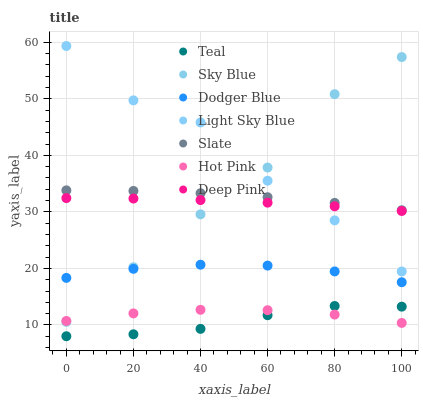Does Teal have the minimum area under the curve?
Answer yes or no. Yes. Does Light Sky Blue have the maximum area under the curve?
Answer yes or no. Yes. Does Slate have the minimum area under the curve?
Answer yes or no. No. Does Slate have the maximum area under the curve?
Answer yes or no. No. Is Deep Pink the smoothest?
Answer yes or no. Yes. Is Light Sky Blue the roughest?
Answer yes or no. Yes. Is Slate the smoothest?
Answer yes or no. No. Is Slate the roughest?
Answer yes or no. No. Does Teal have the lowest value?
Answer yes or no. Yes. Does Hot Pink have the lowest value?
Answer yes or no. No. Does Light Sky Blue have the highest value?
Answer yes or no. Yes. Does Slate have the highest value?
Answer yes or no. No. Is Deep Pink less than Slate?
Answer yes or no. Yes. Is Dodger Blue greater than Teal?
Answer yes or no. Yes. Does Light Sky Blue intersect Slate?
Answer yes or no. Yes. Is Light Sky Blue less than Slate?
Answer yes or no. No. Is Light Sky Blue greater than Slate?
Answer yes or no. No. Does Deep Pink intersect Slate?
Answer yes or no. No. 